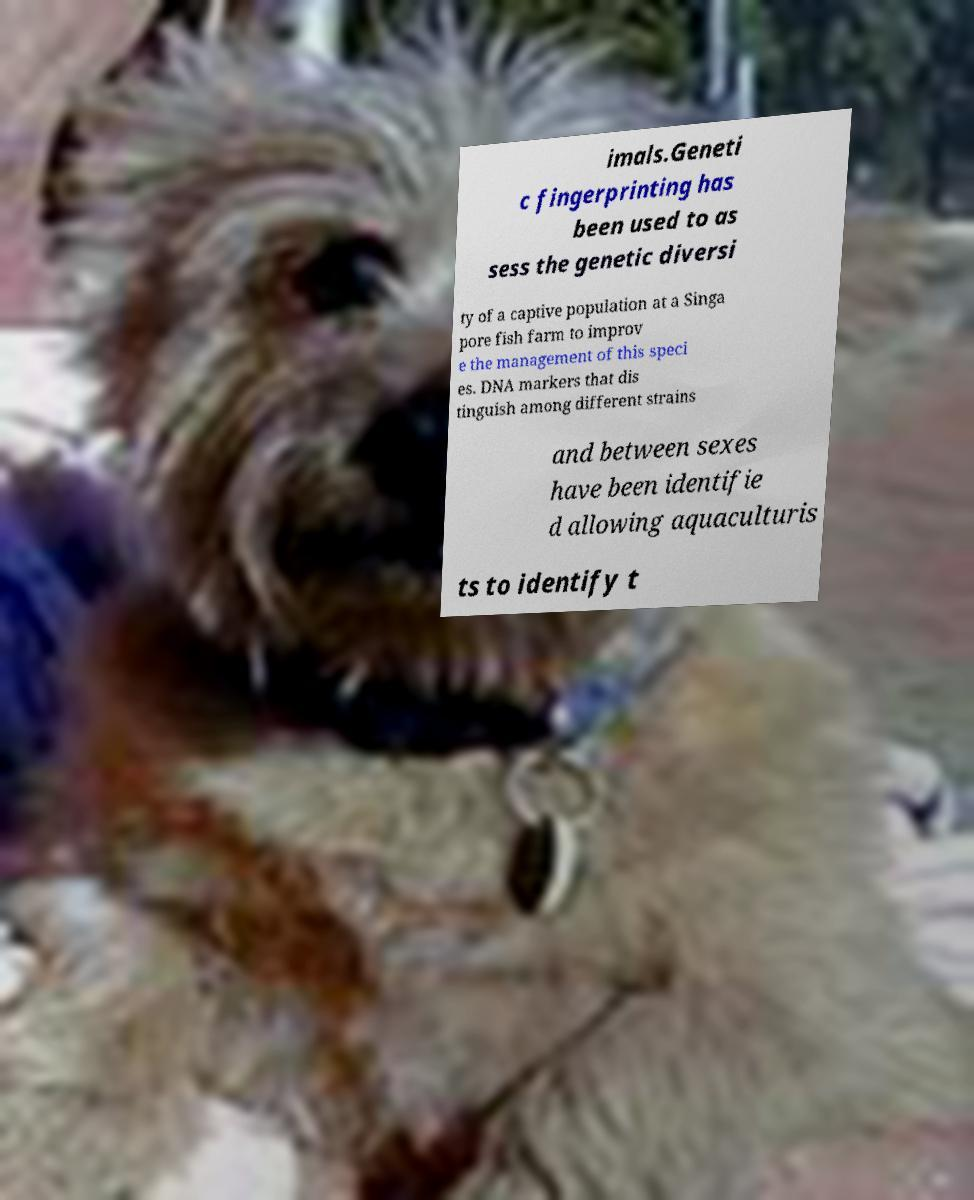For documentation purposes, I need the text within this image transcribed. Could you provide that? imals.Geneti c fingerprinting has been used to as sess the genetic diversi ty of a captive population at a Singa pore fish farm to improv e the management of this speci es. DNA markers that dis tinguish among different strains and between sexes have been identifie d allowing aquaculturis ts to identify t 